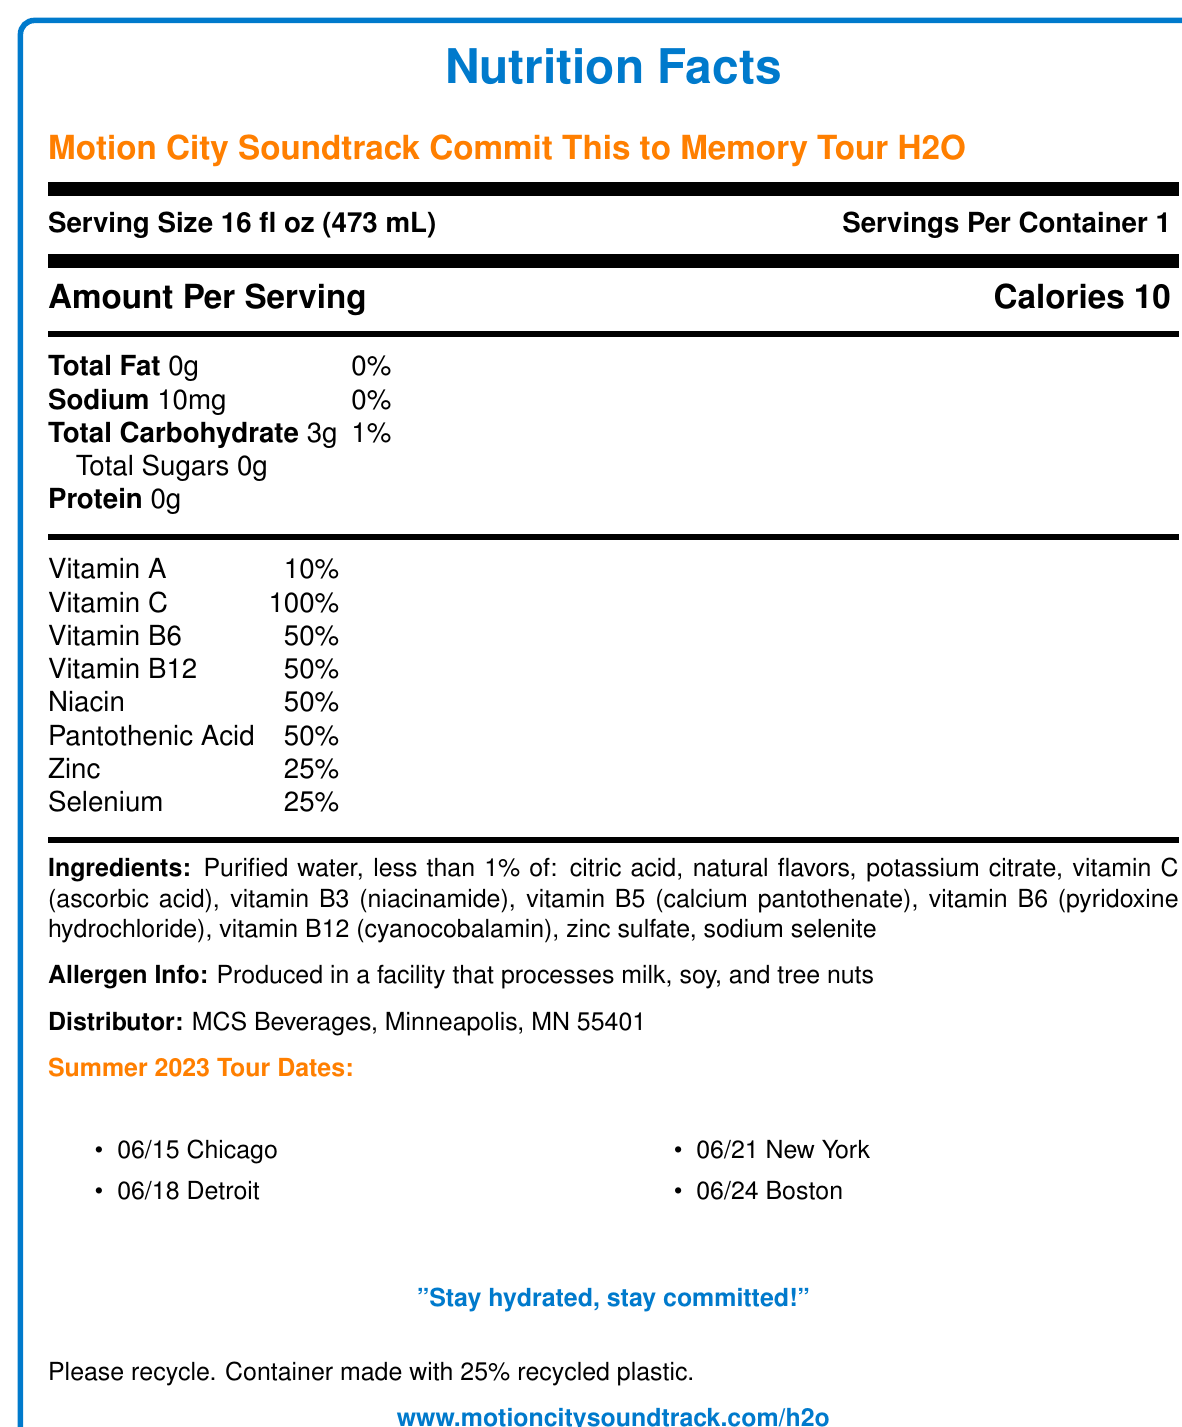what is the serving size? The serving size is clearly mentioned as "16 fl oz (473 mL)" on the document.
Answer: 16 fl oz (473 mL) how many calories are there per serving? The amount of calories per serving is stated as "Calories 10".
Answer: 10 what is the percentage of daily value for Vitamin C? The document specifies that the daily value for Vitamin C is 100%.
Answer: 100% what ingredients are included in less than 1%? The ingredients listed as less than 1% are "citric acid, natural flavors, potassium citrate, vitamin C (ascorbic acid), vitamin B3 (niacinamide), vitamin B5 (calcium pantothenate), vitamin B6 (pyridoxine hydrochloride), vitamin B12 (cyanocobalamin), zinc sulfate, sodium selenite".
Answer: citric acid, natural flavors, potassium citrate, vitamin C (ascorbic acid), vitamin B3 (niacinamide), vitamin B5 (calcium pantothenate), vitamin B6 (pyridoxine hydrochloride), vitamin B12 (cyanocobalamin), zinc sulfate, sodium selenite what does the band motto say? The band motto is displayed as "Stay hydrated, stay committed!" in the document.
Answer: "Stay hydrated, stay committed!" how many servings per container? The document mentions "Servings Per Container 1".
Answer: 1 who is the distributor of this water? The distributor is listed as "MCS Beverages, Minneapolis, MN 55401".
Answer: MCS Beverages, Minneapolis, MN 55401 which of the following is NOT a vitamin included in the water? A. Vitamin A B. Vitamin K C. Vitamin B6 D. Niacin Vitamin K is not mentioned in the list of vitamins provided on the document.
Answer: B. Vitamin K how much sodium is in each serving? The sodium content per serving is shown as "10mg".
Answer: 10mg what materials are the container made with? A. 100% new plastic B. 100% recycled plastic C. 25% recycled plastic D. Glass The document states, "Container made with 25% recycled plastic".
Answer: C. 25% recycled plastic is this product suitable for individuals with soy allergies? The allergen info indicates "Produced in a facility that processes ... soy", meaning it may not be suitable for individuals with soy allergies.
Answer: No summarize the main idea of the document. The document includes nutrition facts for a special edition water product related to Motion City Soundtrack's tour, detailing serving size, nutritional content, ingredients, and association with the band's summer tour dates.
Answer: The document provides nutrition facts and information about a vitamin-fortified water branded by Motion City Soundtrack, including serving size, calorie content, vitamins, ingredients, allergen info, distributor, and tour dates. what is the company's website? The website is given as "www.motioncitysoundtrack.com/h2o".
Answer: www.motioncitysoundtrack.com/h2o how many grams of protein does the water contain? The protein content per serving is listed as "0g".
Answer: 0g which city is not listed as a tour date for Summer 2023? A. Chicago B. Detroit C. New York D. Los Angeles The tour dates include Chicago, Detroit, New York, and Boston, but not Los Angeles.
Answer: D. Los Angeles what is the date for the New York tour event? The tour date for New York is specified as "06/21".
Answer: 06/21 how many grams of total carbohydrates are there in each serving? The document indicates the total carbohydrate content as "3g".
Answer: 3g who manufactured the vitamins in the water? The document does not provide information about the manufacturer of the vitamins.
Answer: Cannot be determined 